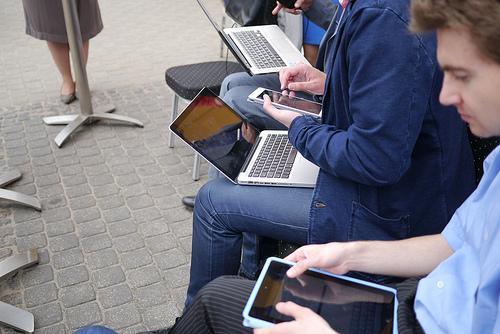How many people are reading book?
Give a very brief answer. 0. 